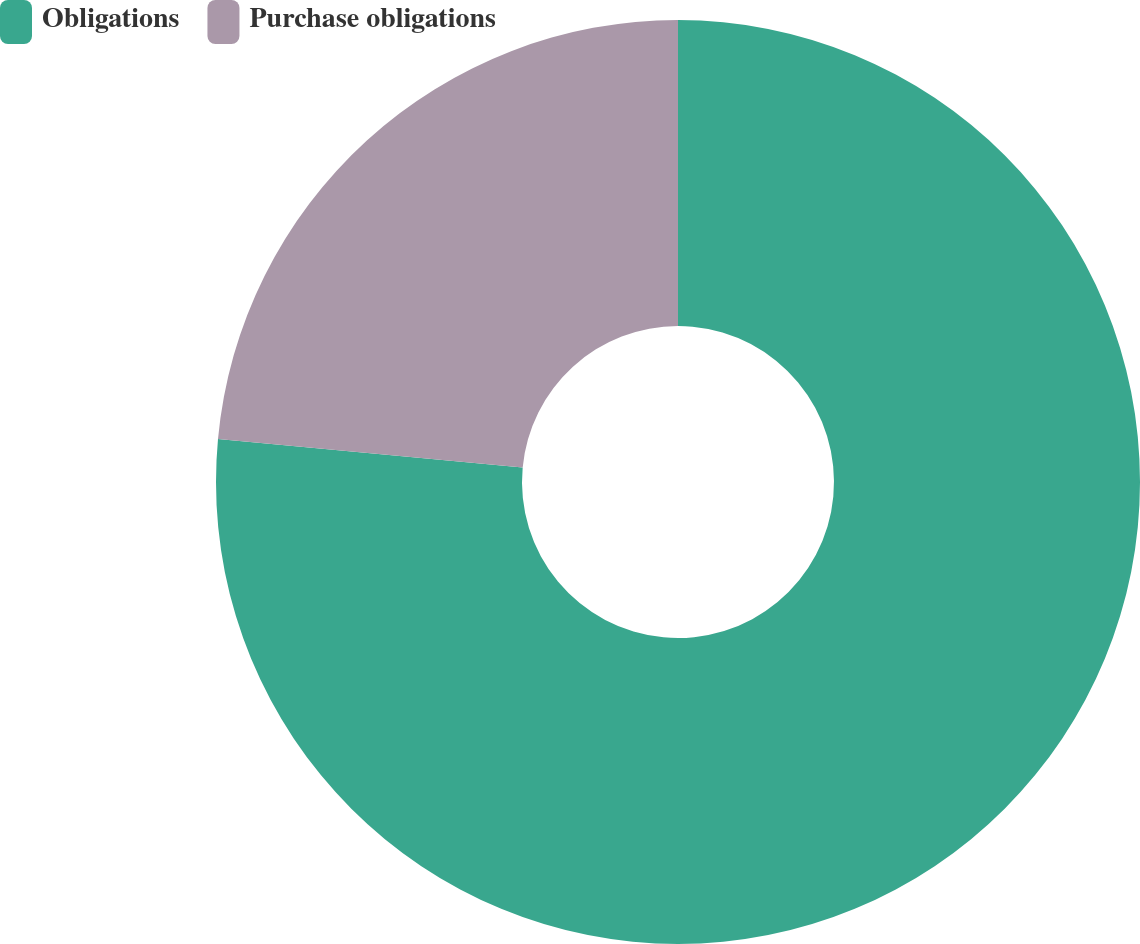Convert chart to OTSL. <chart><loc_0><loc_0><loc_500><loc_500><pie_chart><fcel>Obligations<fcel>Purchase obligations<nl><fcel>76.48%<fcel>23.52%<nl></chart> 